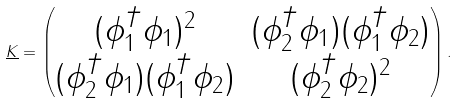Convert formula to latex. <formula><loc_0><loc_0><loc_500><loc_500>\underline { K } = \begin{pmatrix} ( \phi _ { 1 } ^ { \dag } \phi _ { 1 } ) ^ { 2 } & ( \phi _ { 2 } ^ { \dag } \phi _ { 1 } ) ( \phi _ { 1 } ^ { \dag } \phi _ { 2 } ) \\ ( \phi _ { 2 } ^ { \dag } \phi _ { 1 } ) ( \phi _ { 1 } ^ { \dag } \phi _ { 2 } ) & ( \phi _ { 2 } ^ { \dag } \phi _ { 2 } ) ^ { 2 } \end{pmatrix} .</formula> 